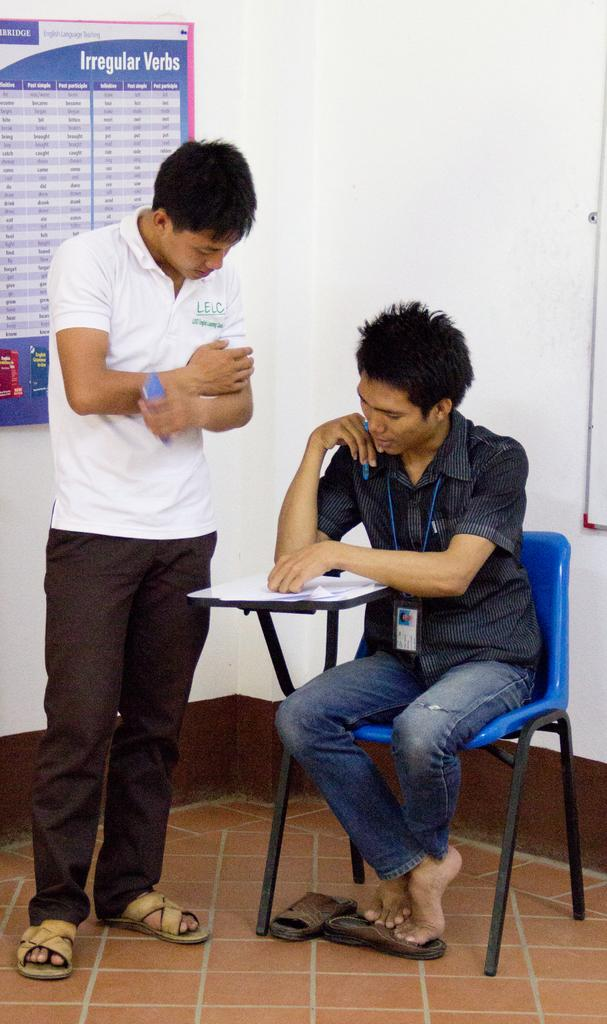How many men are present in the image? There are two men in the image, one standing and one sitting. What is the sitting man wearing? The sitting man is wearing an ID card. What can be seen on the table in the image? There are papers on the table in the image. What type of wool is being spun by the man in the image? There is no wool or spinning activity present in the image. How many icicles are hanging from the roof in the image? There is no roof or icicles present in the image. 